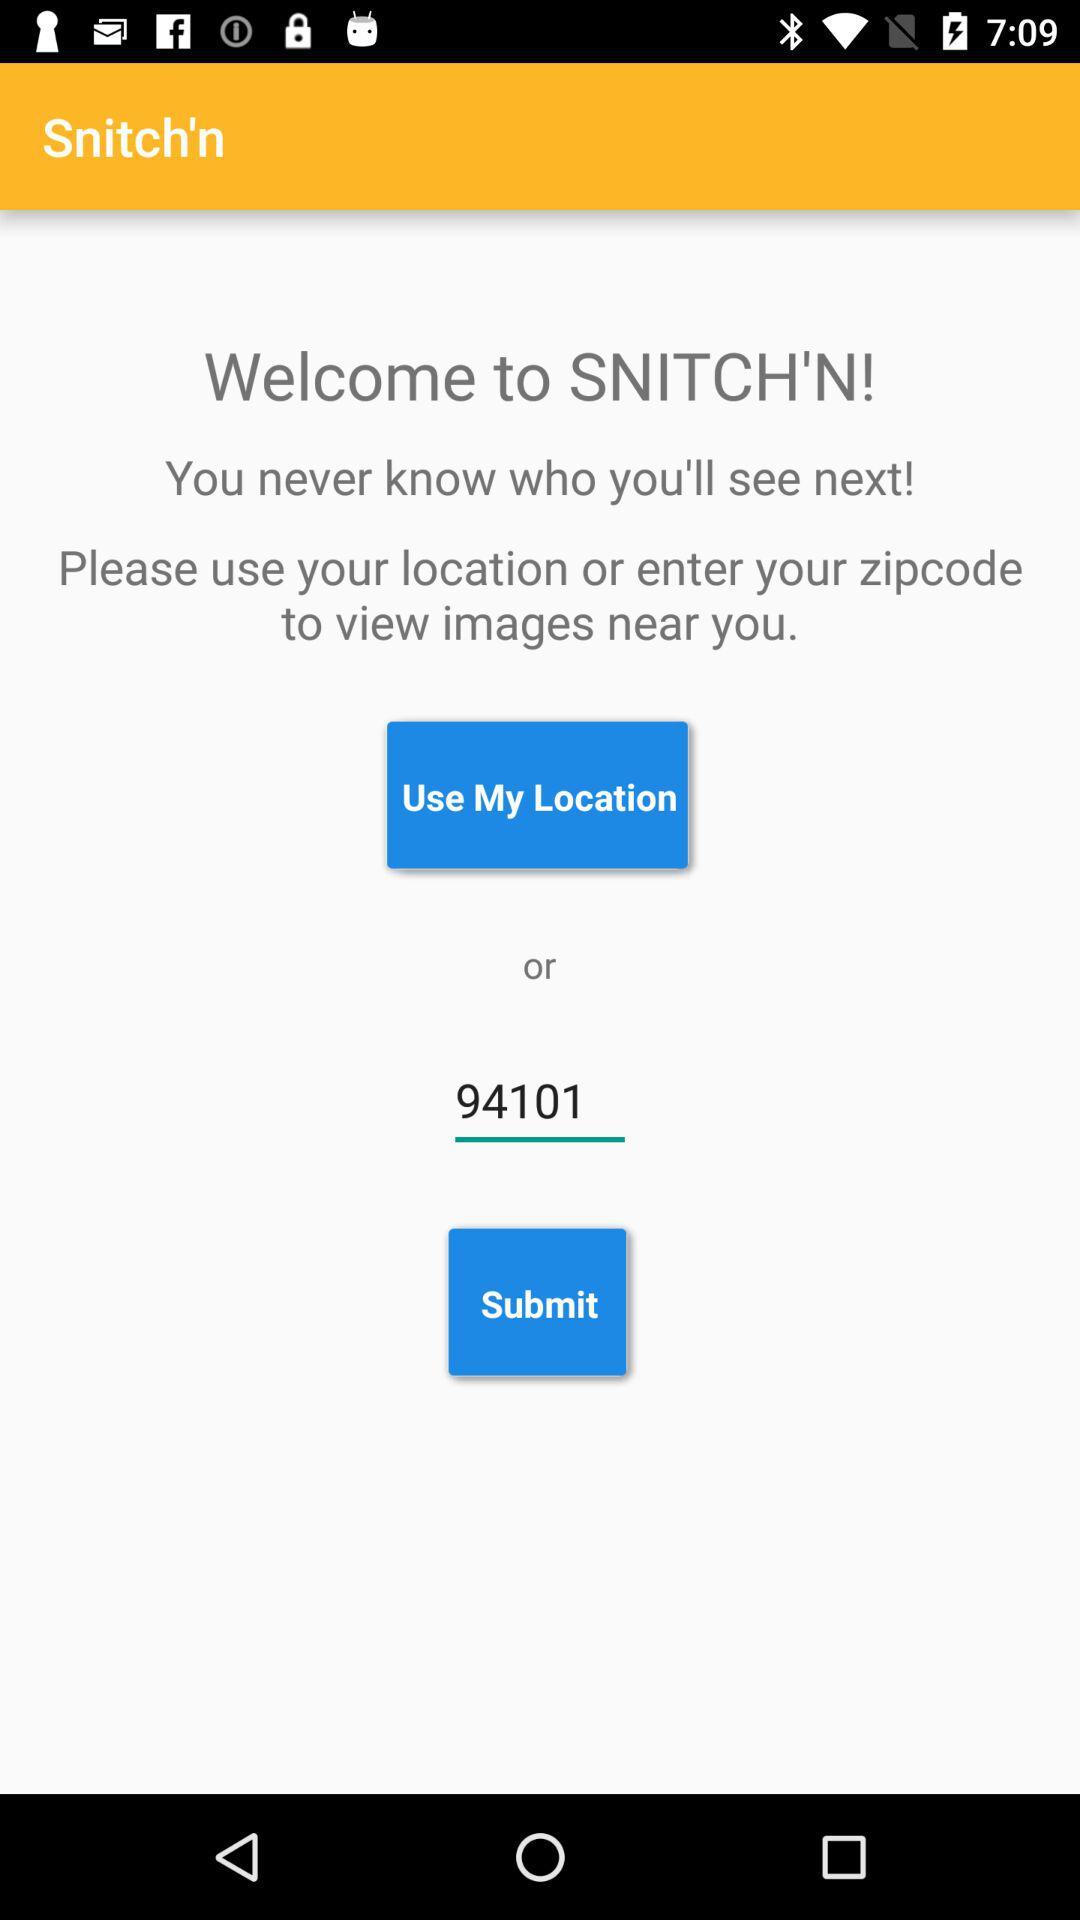What is the application name? The application name is "Snitch'n". 